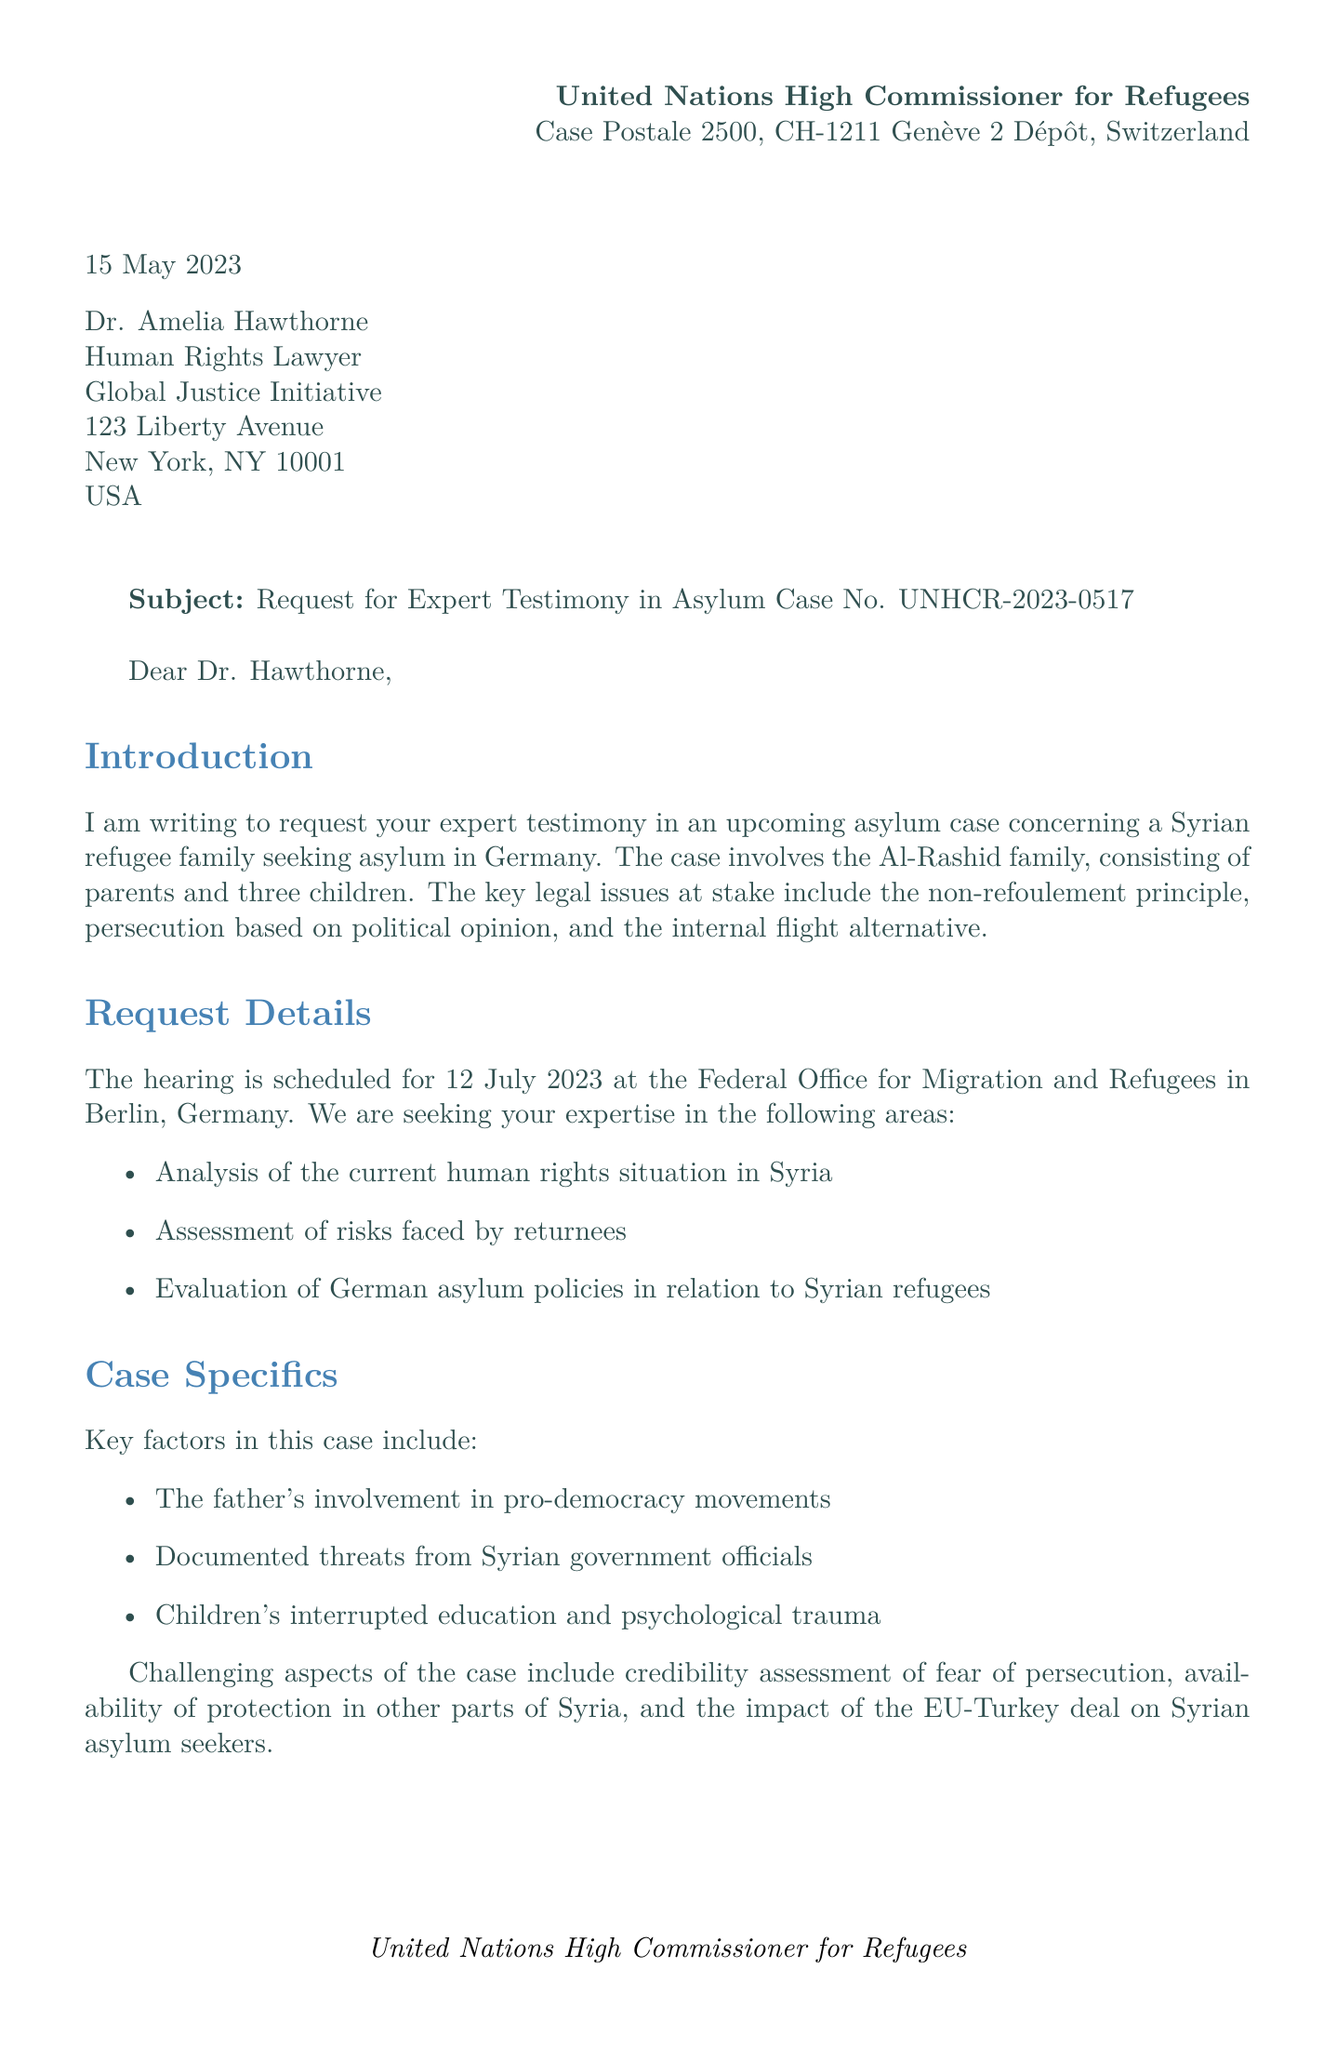What is the date of the letter? The date of the letter is mentioned in the document as "15 May 2023."
Answer: 15 May 2023 Who is the recipient of the letter? The recipient of the letter is listed in the document as Dr. Amelia Hawthorne.
Answer: Dr. Amelia Hawthorne What is the subject of the letter? The subject line of the letter specifies the purpose of the correspondence: "Request for Expert Testimony in Asylum Case No. UNHCR-2023-0517."
Answer: Request for Expert Testimony in Asylum Case No. UNHCR-2023-0517 What is the hearing date mentioned in the letter? The hearing date is specifically stated in the request details section as "12 July 2023."
Answer: 12 July 2023 What are the key factors in this asylum case? Key factors include the father's involvement in pro-democracy movements and documented threats among others.
Answer: Father's involvement in pro-democracy movements What are the expectations regarding the testimony format? The document specifies that both a written report and oral testimony are expected.
Answer: Written report and oral testimony How many children are in the Al-Rashid family? The document states that the Al-Rashid family consists of parents and three children.
Answer: three children Who should be contacted for further questions? The letter provides contact information for Ms. Fatima Khalil, who is the UNHCR Case Officer.
Answer: Ms. Fatima Khalil What is the compensation basis for the expert witness? Compensation will be provided as per the UNHCR expert witness fee schedule.
Answer: UNHCR expert witness fee schedule 